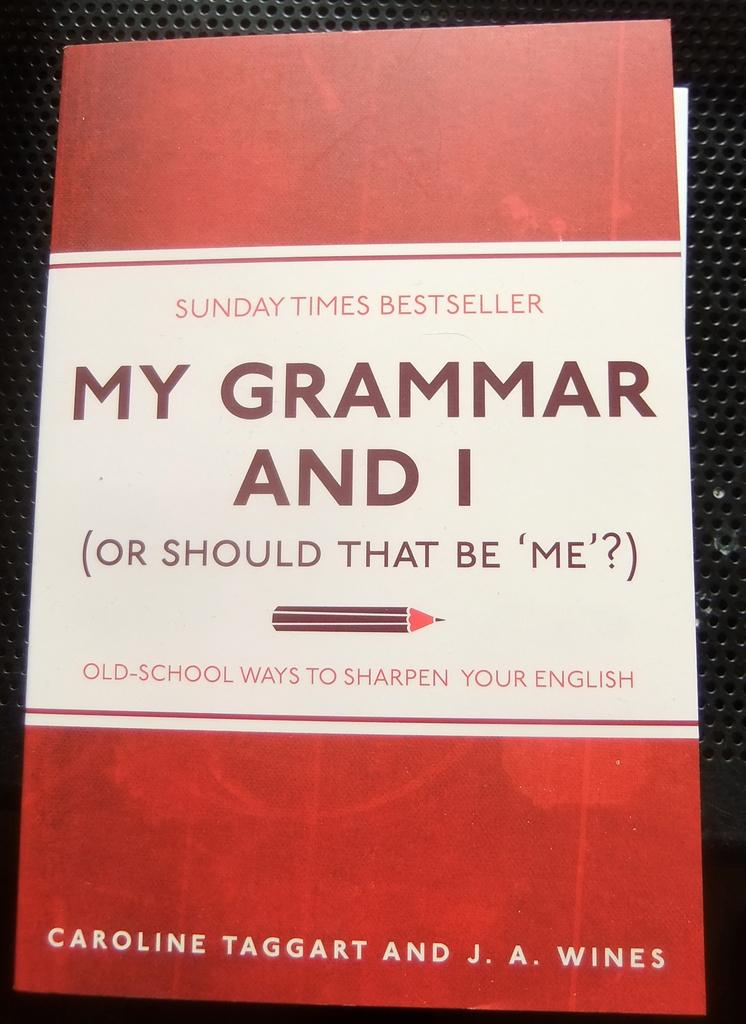<image>
Describe the image concisely. A book titles My Grammar and I has a red and white cover. 